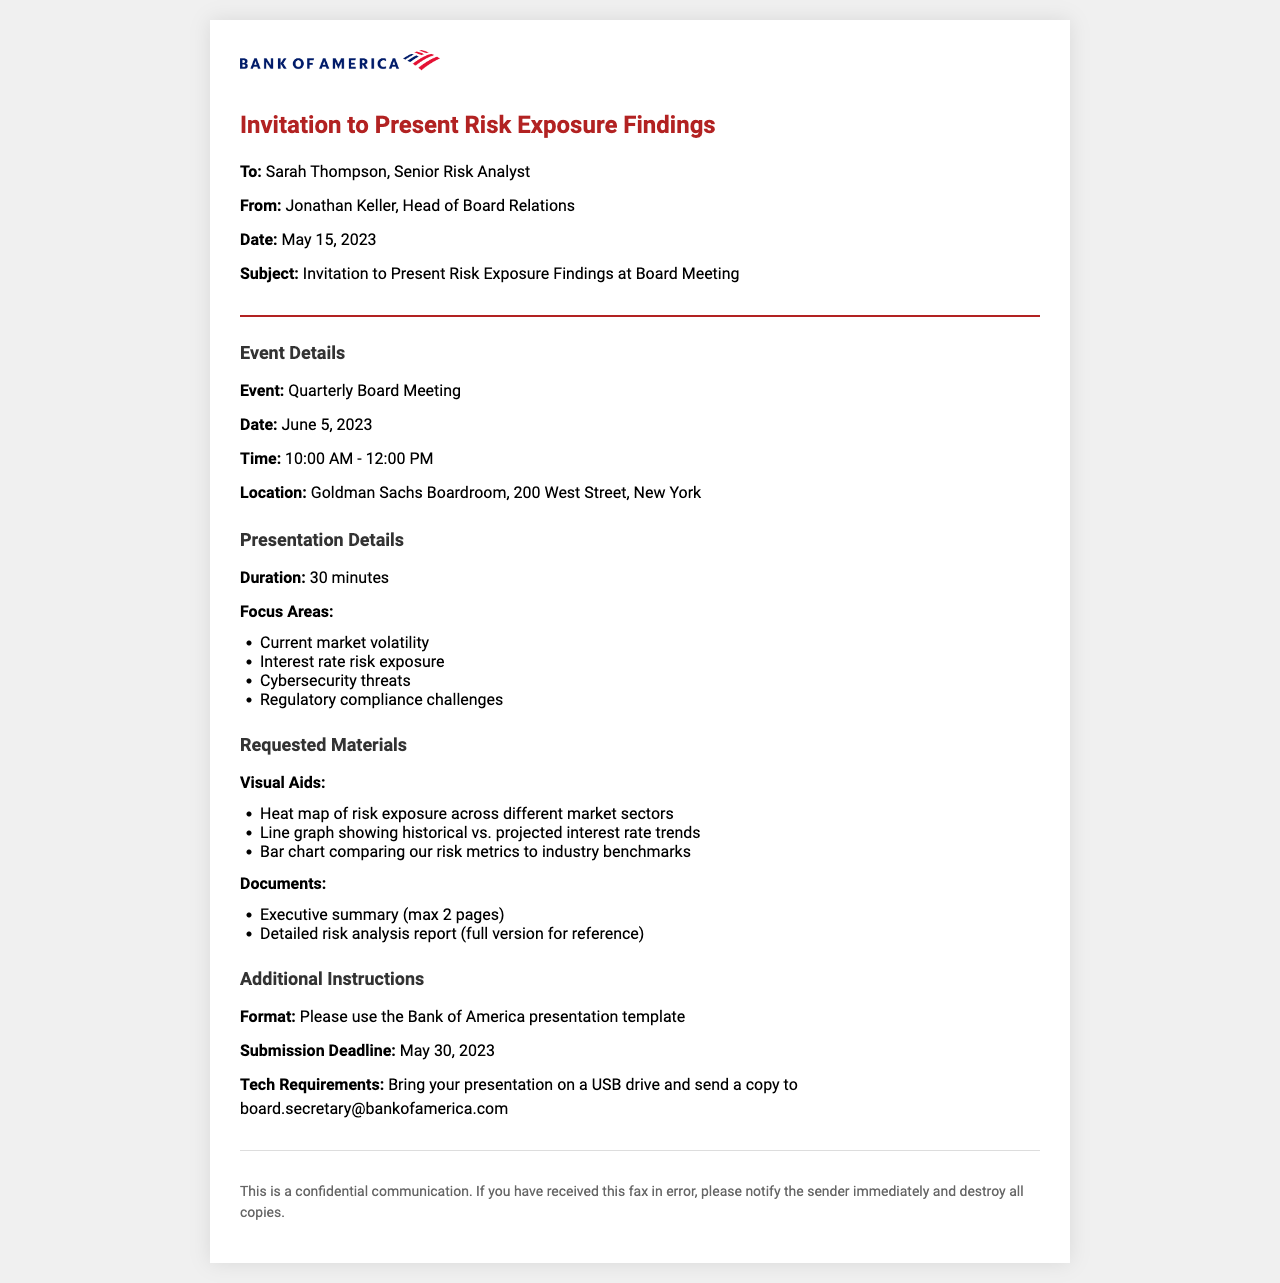What is the date of the board meeting? The date of the board meeting is mentioned explicitly in the event details section, which states June 5, 2023.
Answer: June 5, 2023 Who sent the invitation? The sender of the invitation is explicitly listed at the top of the document, which states Jonathan Keller, Head of Board Relations.
Answer: Jonathan Keller What is the duration of the presentation? The duration is specified in the presentation details section, which mentions a 30-minute timeframe.
Answer: 30 minutes What is the submission deadline for materials? The submission deadline is clearly stated in the additional instructions, which specifies May 30, 2023.
Answer: May 30, 2023 What type of visual aid is requested to compare risk metrics? The requested visual aid is detailed in the materials section, specifically mentioning a bar chart for comparison to industry benchmarks.
Answer: Bar chart comparing our risk metrics to industry benchmarks How many focus areas are listed for the presentation? The number of focus areas can be counted from the list provided in the presentation details section, which contains four items.
Answer: Four What is the location of the board meeting? The location is specified in the event details section, which provides the address as Goldman Sachs Boardroom, 200 West Street, New York.
Answer: Goldman Sachs Boardroom, 200 West Street, New York What type of document is requested alongside the presentation? The types of documents requested are listed in the materials section; specifically, an executive summary and a detailed risk analysis report.
Answer: Executive summary and detailed risk analysis report 